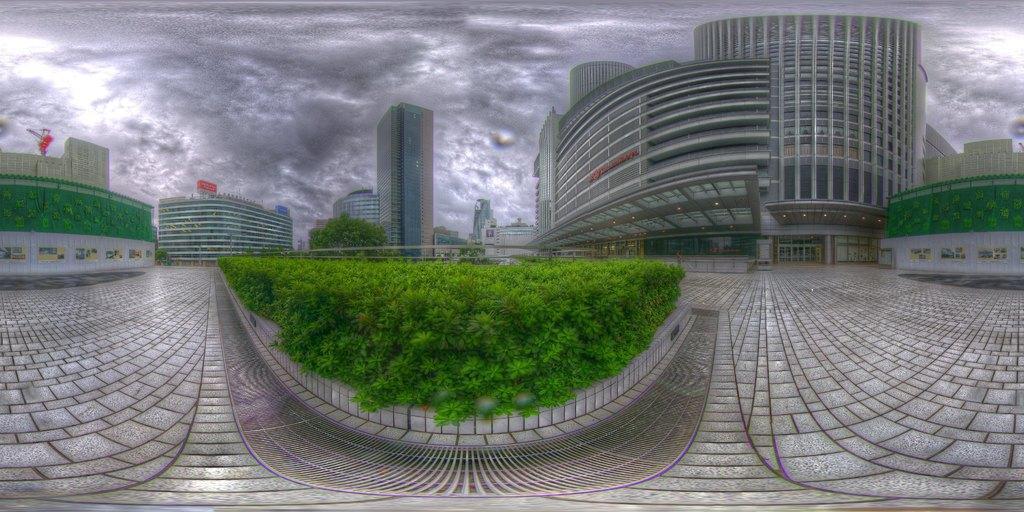Can you describe this image briefly? In the image we can see there are many buildings. This is a footpath, grass, window of the building and a gray cloudy sky. 